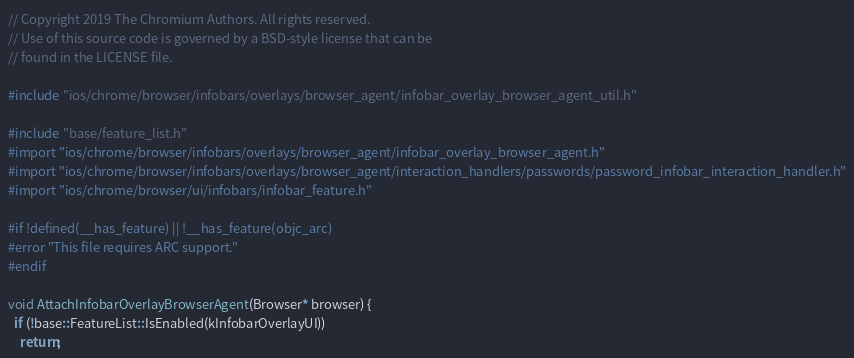Convert code to text. <code><loc_0><loc_0><loc_500><loc_500><_ObjectiveC_>// Copyright 2019 The Chromium Authors. All rights reserved.
// Use of this source code is governed by a BSD-style license that can be
// found in the LICENSE file.

#include "ios/chrome/browser/infobars/overlays/browser_agent/infobar_overlay_browser_agent_util.h"

#include "base/feature_list.h"
#import "ios/chrome/browser/infobars/overlays/browser_agent/infobar_overlay_browser_agent.h"
#import "ios/chrome/browser/infobars/overlays/browser_agent/interaction_handlers/passwords/password_infobar_interaction_handler.h"
#import "ios/chrome/browser/ui/infobars/infobar_feature.h"

#if !defined(__has_feature) || !__has_feature(objc_arc)
#error "This file requires ARC support."
#endif

void AttachInfobarOverlayBrowserAgent(Browser* browser) {
  if (!base::FeatureList::IsEnabled(kInfobarOverlayUI))
    return;</code> 